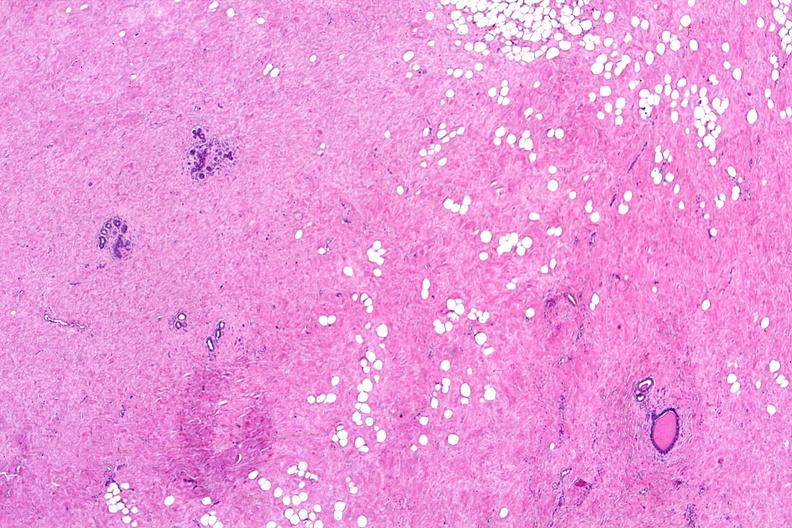what is present?
Answer the question using a single word or phrase. Female reproductive 